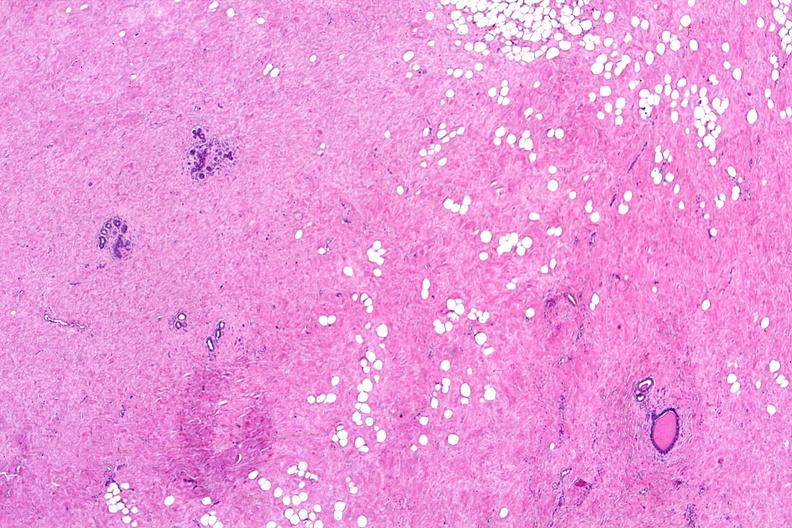what is present?
Answer the question using a single word or phrase. Female reproductive 